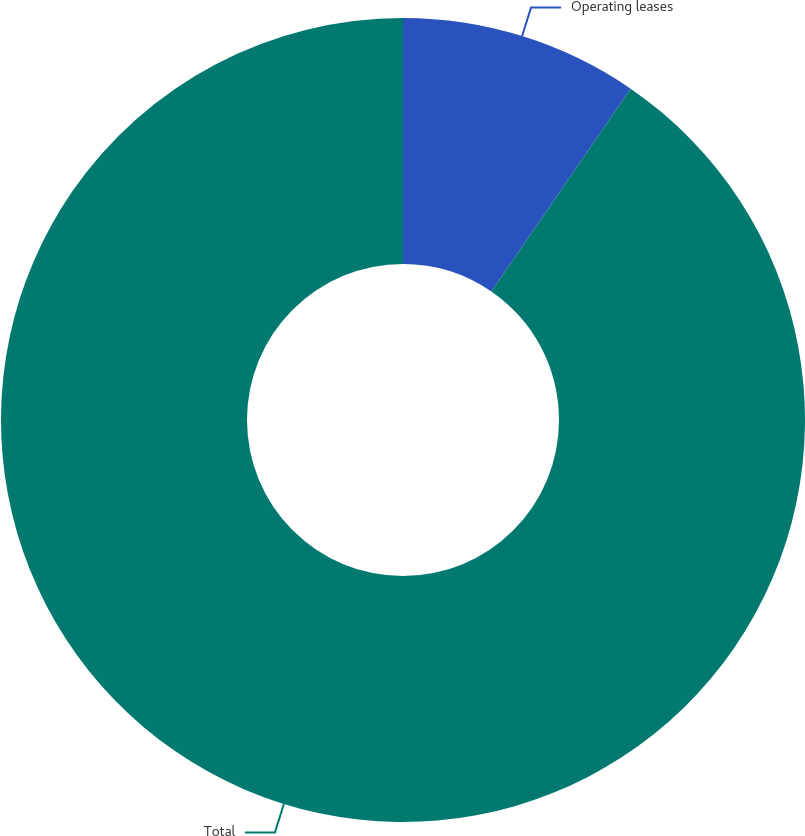Convert chart. <chart><loc_0><loc_0><loc_500><loc_500><pie_chart><fcel>Operating leases<fcel>Total<nl><fcel>9.58%<fcel>90.42%<nl></chart> 